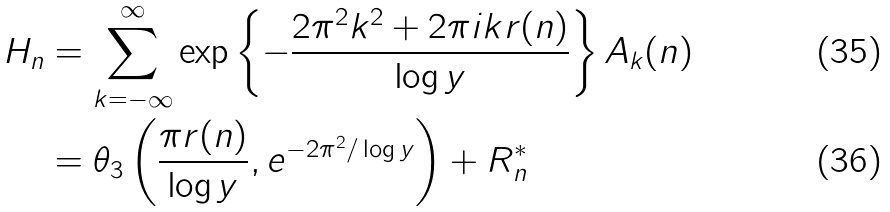Convert formula to latex. <formula><loc_0><loc_0><loc_500><loc_500>H _ { n } & = \sum _ { k = - \infty } ^ { \infty } \exp \left \{ - \frac { 2 \pi ^ { 2 } k ^ { 2 } + 2 \pi i k r ( n ) } { \log y } \right \} A _ { k } ( n ) \\ & = \theta _ { 3 } \left ( \frac { \pi r ( n ) } { \log y } , e ^ { - 2 \pi ^ { 2 } / \log y } \right ) + R _ { n } ^ { \ast }</formula> 